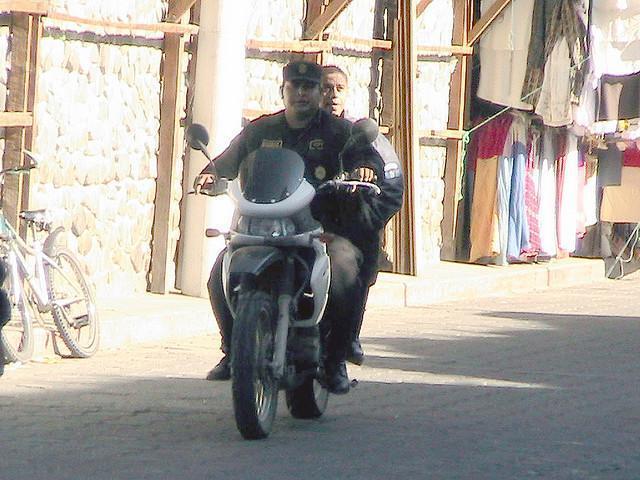How many people on the bike?
Give a very brief answer. 2. How many people are there?
Give a very brief answer. 3. 